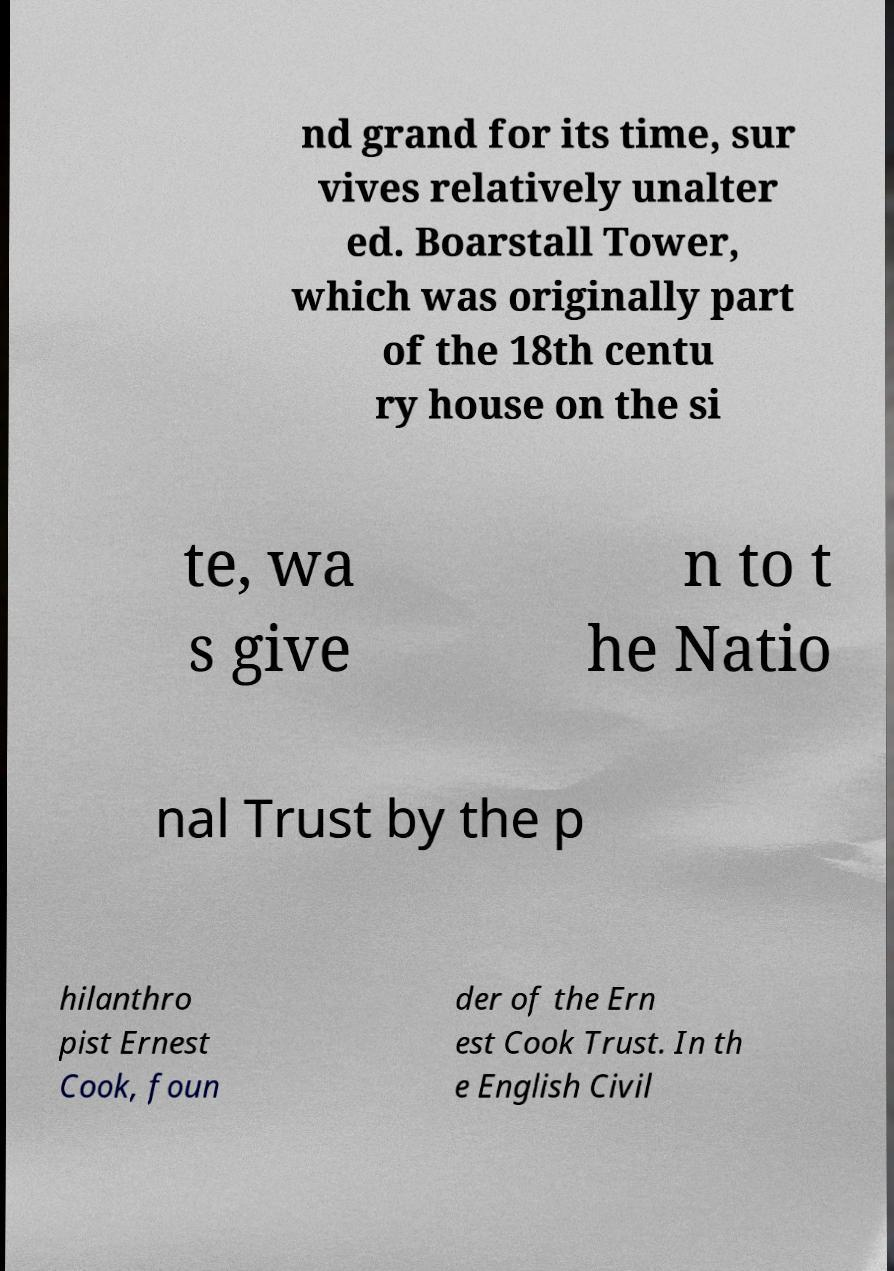Could you extract and type out the text from this image? nd grand for its time, sur vives relatively unalter ed. Boarstall Tower, which was originally part of the 18th centu ry house on the si te, wa s give n to t he Natio nal Trust by the p hilanthro pist Ernest Cook, foun der of the Ern est Cook Trust. In th e English Civil 